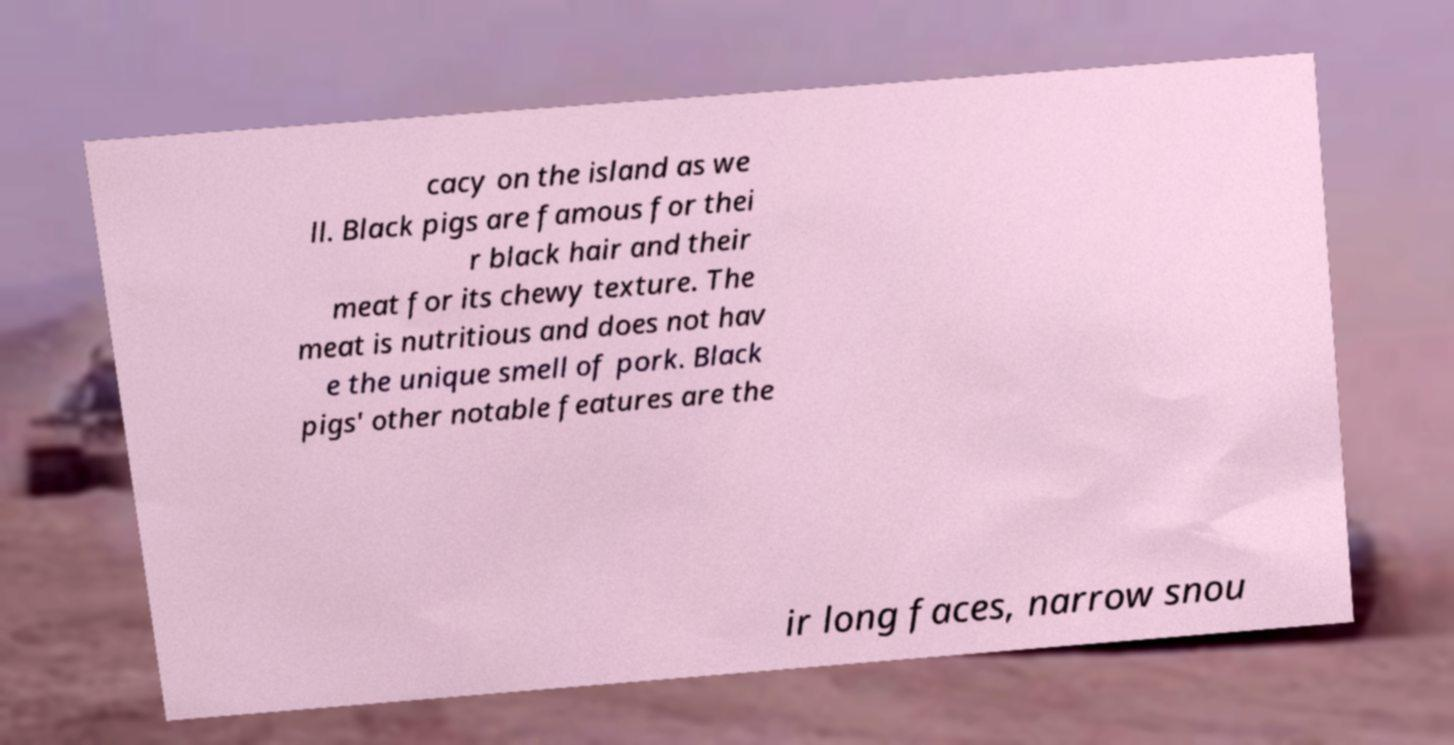Please read and relay the text visible in this image. What does it say? cacy on the island as we ll. Black pigs are famous for thei r black hair and their meat for its chewy texture. The meat is nutritious and does not hav e the unique smell of pork. Black pigs' other notable features are the ir long faces, narrow snou 